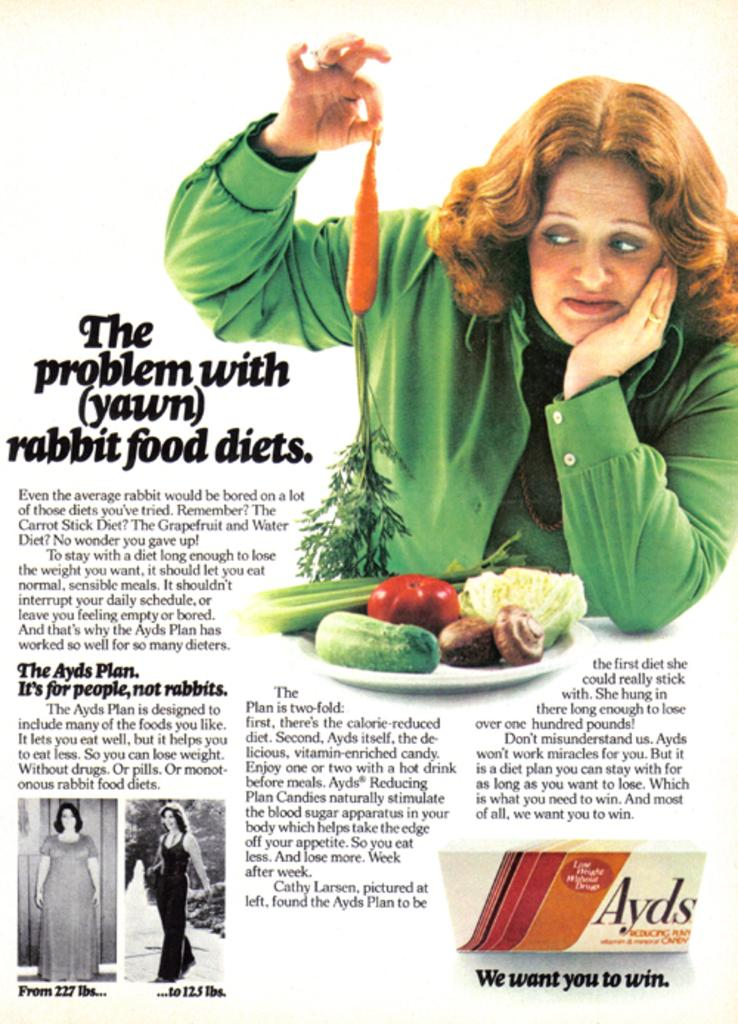Provide a one-sentence caption for the provided image. An ad for Ayds shows a woman with a carrot. 